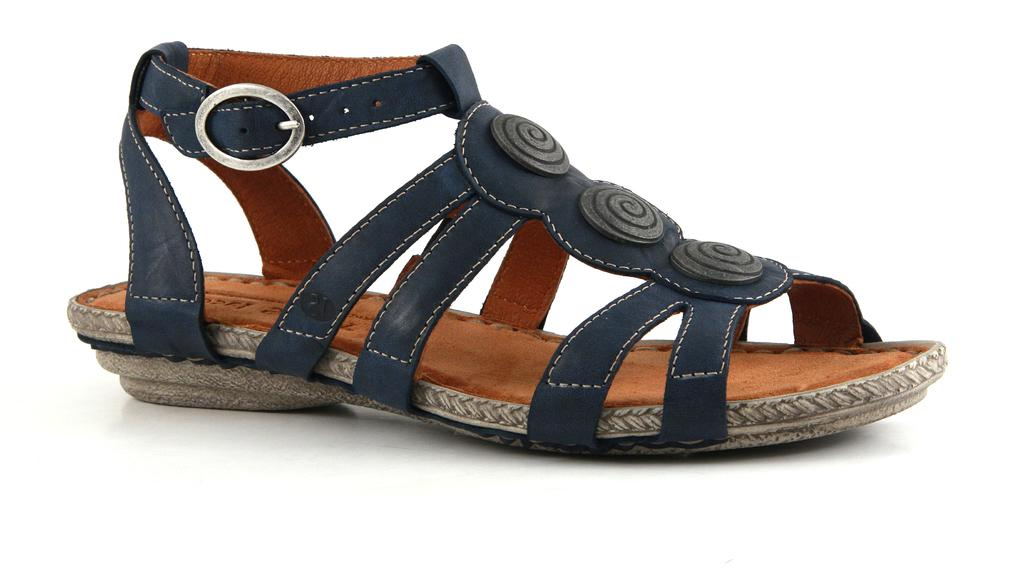What type of footwear is visible in the image? There is footwear in the image, but the specific type is not mentioned. What is the color of the surface on which the footwear is placed? The footwear is on a white surface. How many fingers can be seen touching the footwear in the image? There is no mention of fingers or any other body parts touching the footwear in the image. 